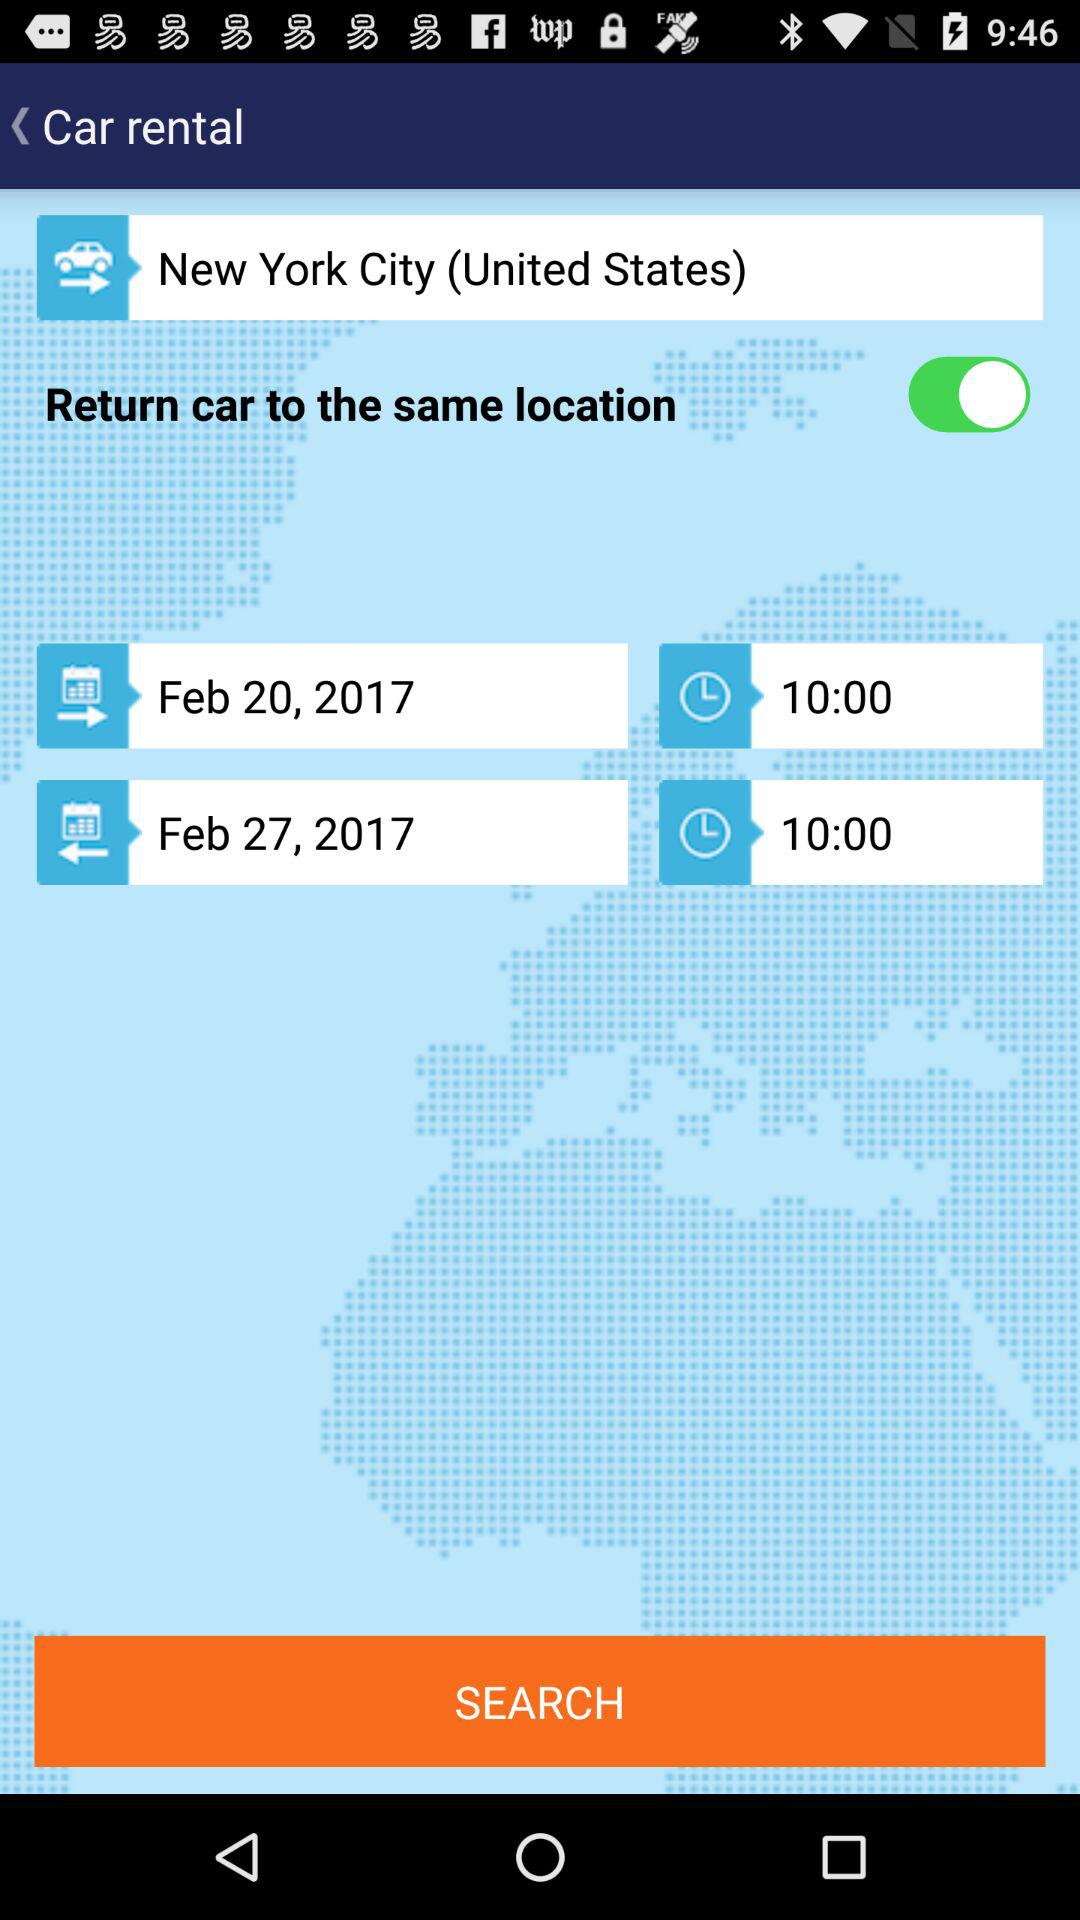What is the arrival time? The arrival time is 10:00. 